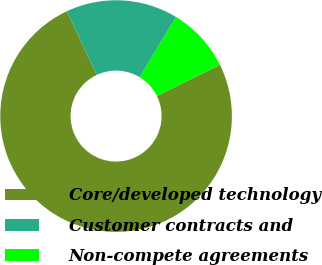Convert chart to OTSL. <chart><loc_0><loc_0><loc_500><loc_500><pie_chart><fcel>Core/developed technology<fcel>Customer contracts and<fcel>Non-compete agreements<nl><fcel>75.3%<fcel>15.66%<fcel>9.04%<nl></chart> 